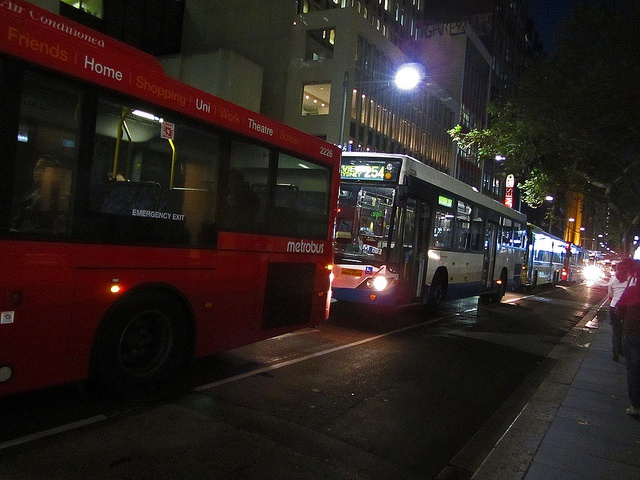Describe the objects in this image and their specific colors. I can see bus in maroon, black, gray, and darkgreen tones, bus in maroon, black, gray, and white tones, people in maroon, black, purple, and darkgray tones, bus in maroon, gray, white, and black tones, and people in black and maroon tones in this image. 